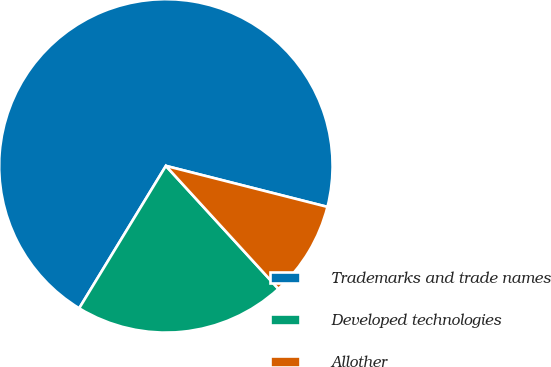Convert chart to OTSL. <chart><loc_0><loc_0><loc_500><loc_500><pie_chart><fcel>Trademarks and trade names<fcel>Developed technologies<fcel>Allother<nl><fcel>70.26%<fcel>20.5%<fcel>9.25%<nl></chart> 